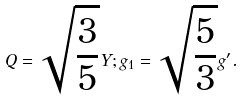<formula> <loc_0><loc_0><loc_500><loc_500>Q = \sqrt { \frac { 3 } { 5 } } Y ; g _ { 1 } = \sqrt { \frac { 5 } { 3 } } g ^ { \prime } .</formula> 